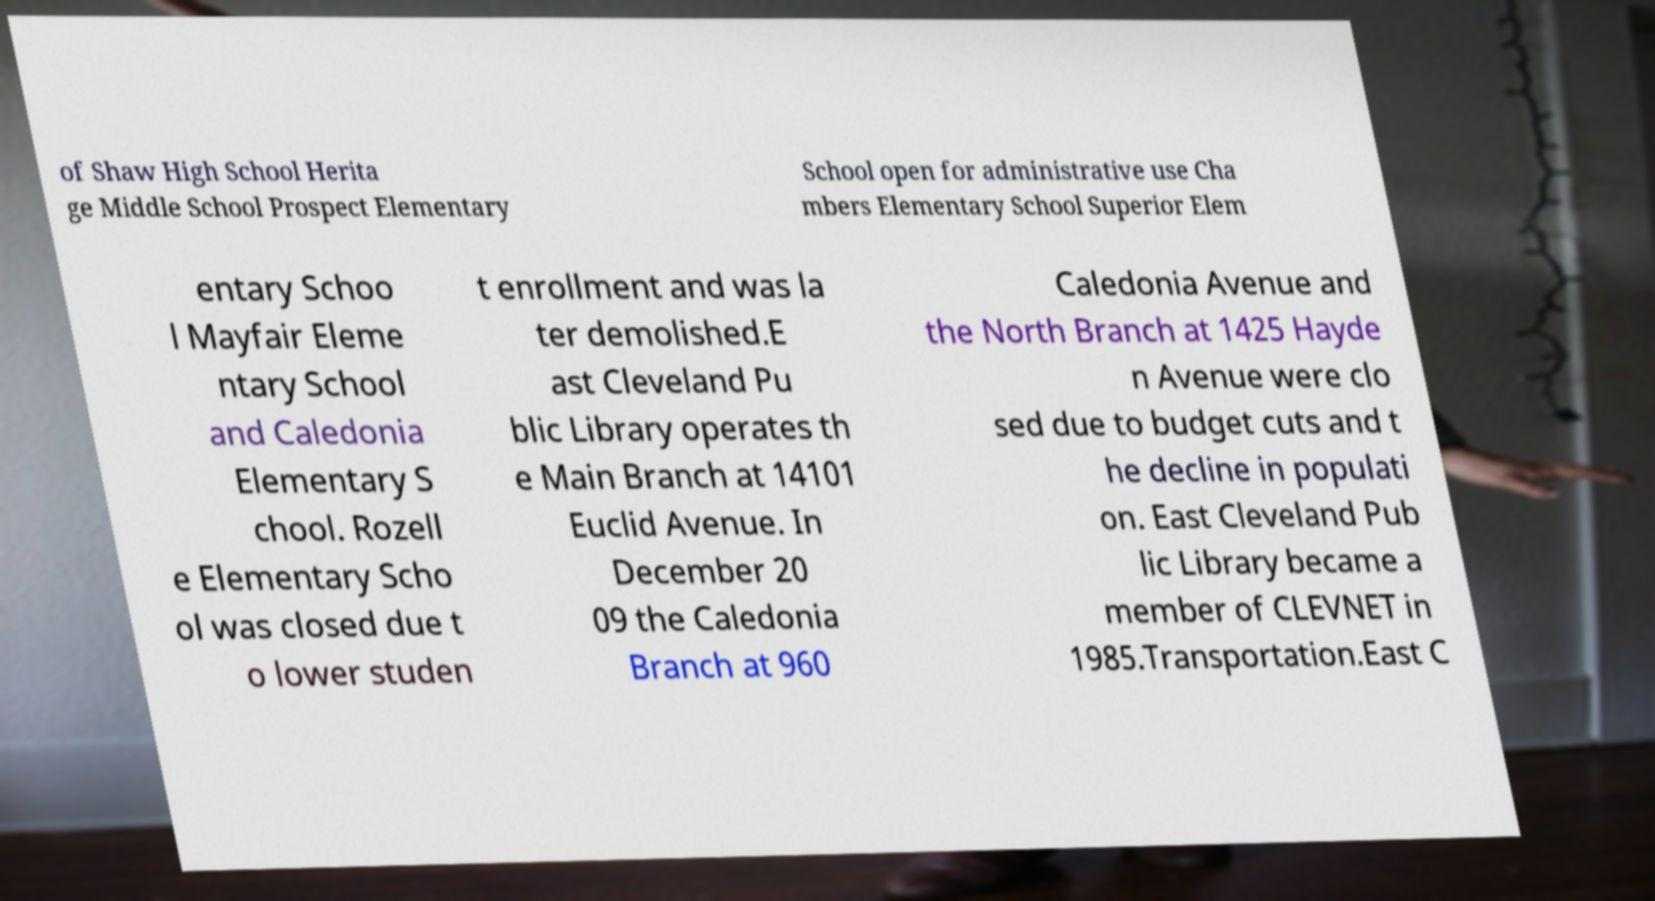I need the written content from this picture converted into text. Can you do that? of Shaw High School Herita ge Middle School Prospect Elementary School open for administrative use Cha mbers Elementary School Superior Elem entary Schoo l Mayfair Eleme ntary School and Caledonia Elementary S chool. Rozell e Elementary Scho ol was closed due t o lower studen t enrollment and was la ter demolished.E ast Cleveland Pu blic Library operates th e Main Branch at 14101 Euclid Avenue. In December 20 09 the Caledonia Branch at 960 Caledonia Avenue and the North Branch at 1425 Hayde n Avenue were clo sed due to budget cuts and t he decline in populati on. East Cleveland Pub lic Library became a member of CLEVNET in 1985.Transportation.East C 